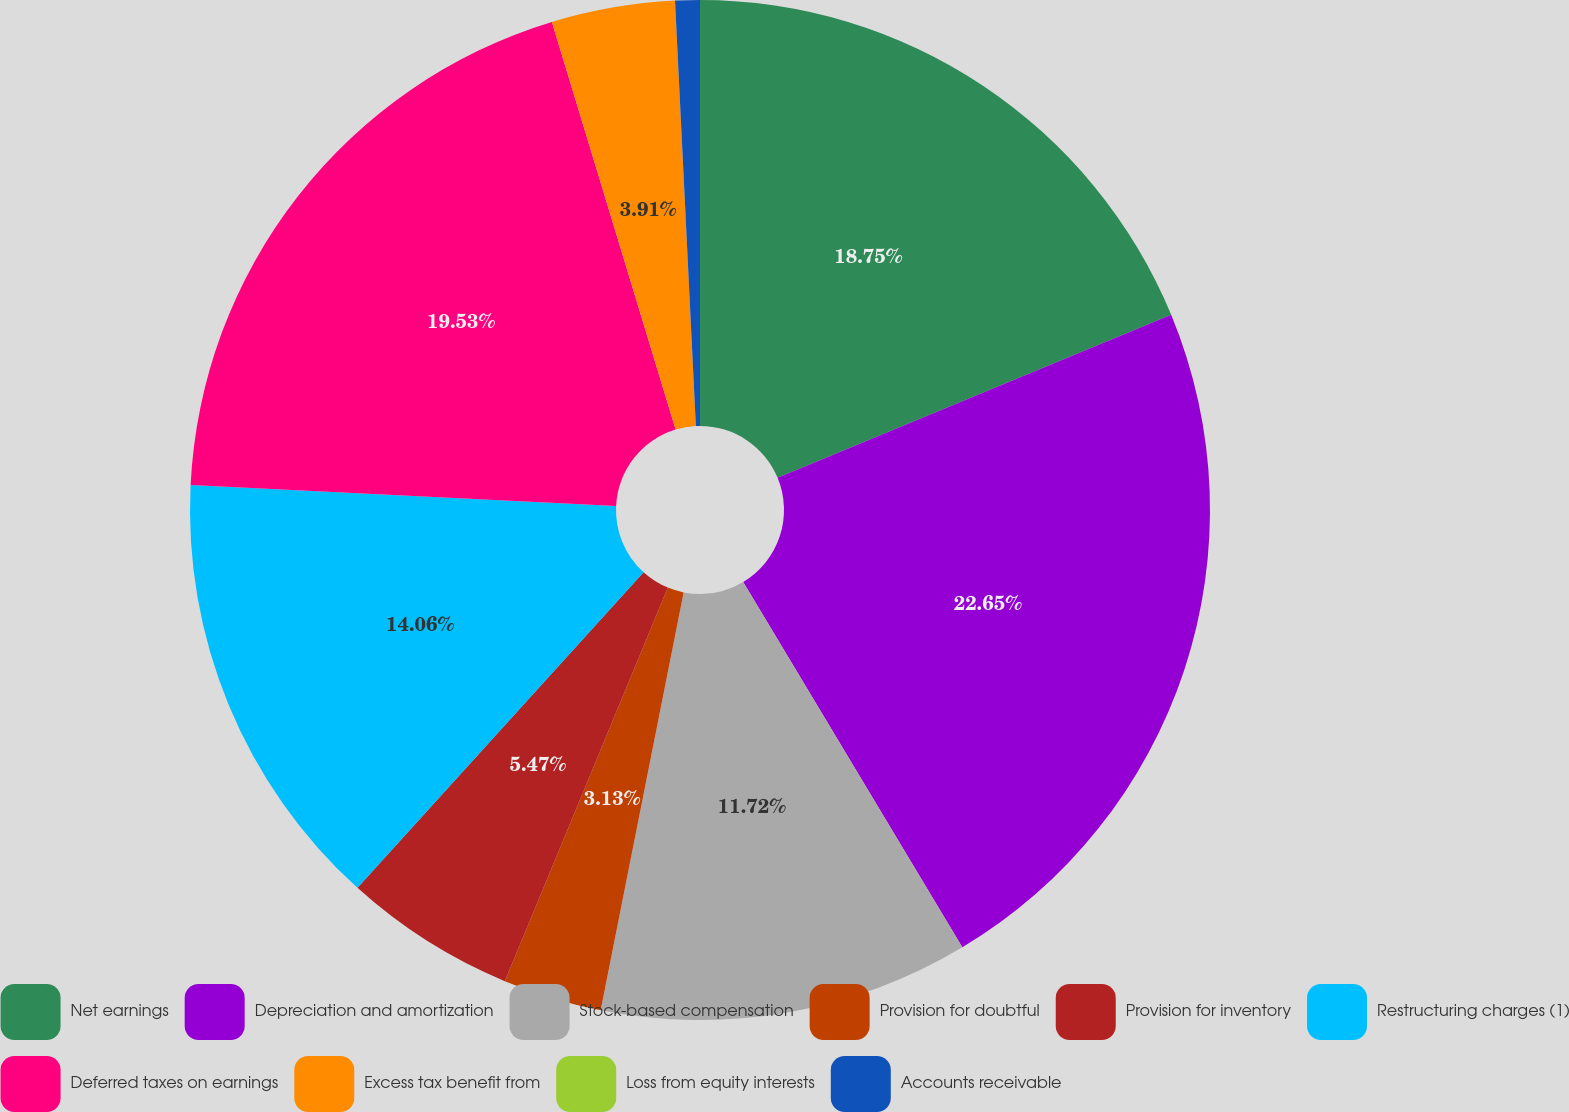<chart> <loc_0><loc_0><loc_500><loc_500><pie_chart><fcel>Net earnings<fcel>Depreciation and amortization<fcel>Stock-based compensation<fcel>Provision for doubtful<fcel>Provision for inventory<fcel>Restructuring charges (1)<fcel>Deferred taxes on earnings<fcel>Excess tax benefit from<fcel>Loss from equity interests<fcel>Accounts receivable<nl><fcel>18.75%<fcel>22.65%<fcel>11.72%<fcel>3.13%<fcel>5.47%<fcel>14.06%<fcel>19.53%<fcel>3.91%<fcel>0.0%<fcel>0.78%<nl></chart> 